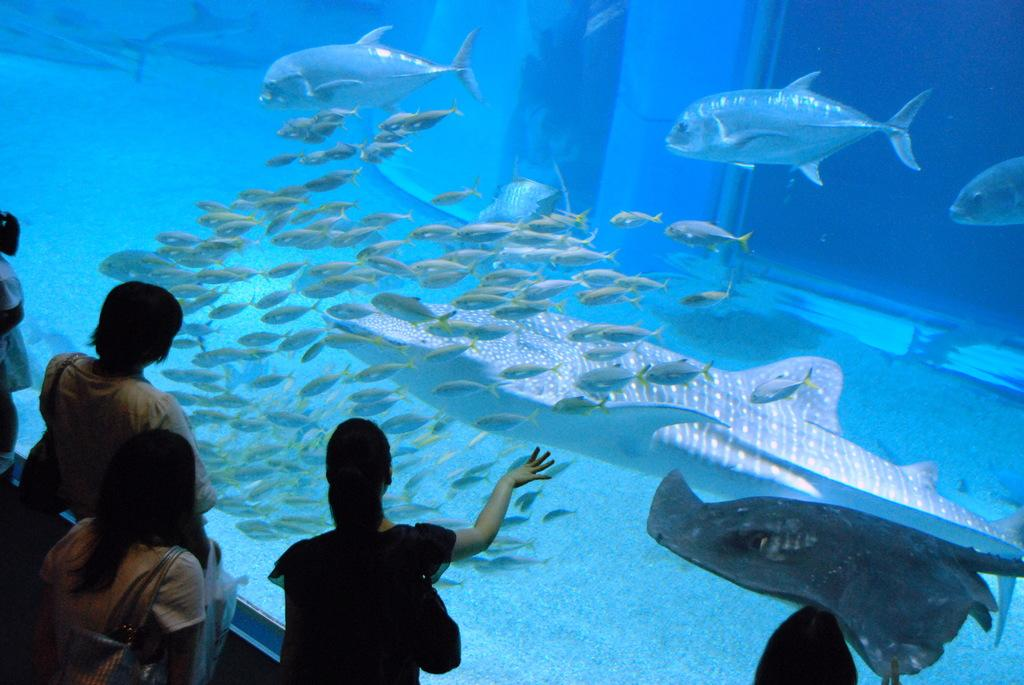What can be seen in the bottom left side of the image? There are people standing in the bottom left side of the image. What is the main feature in the image? There is a big aquarium in the image. What is inside the aquarium? The aquarium contains fish. Can you see a river flowing near the aquarium in the image? There is no river visible in the image; it only features an aquarium with fish. Are there any plastic insects placed near the people in the image? There are no insects, plastic or otherwise, present in the image. 